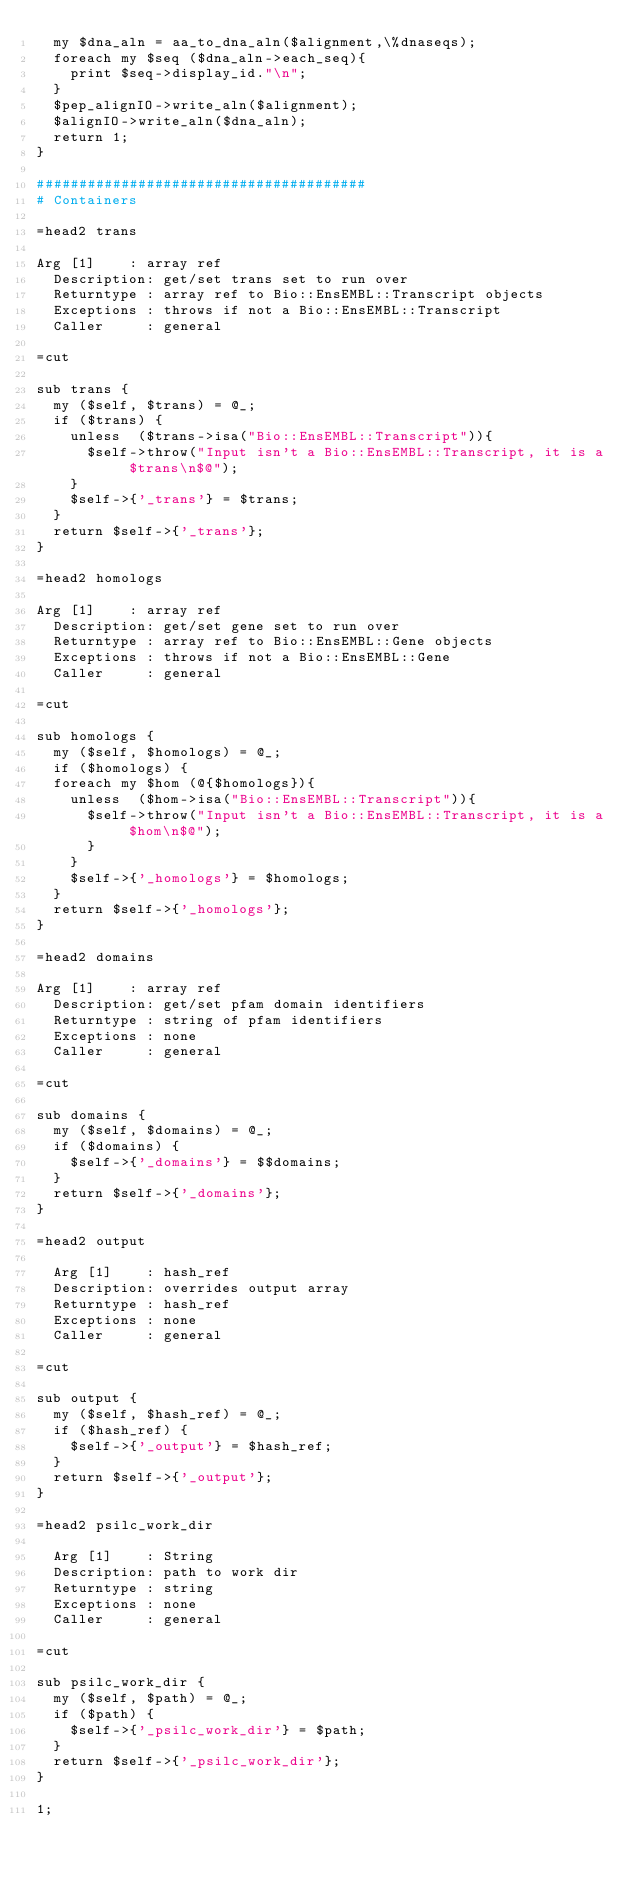<code> <loc_0><loc_0><loc_500><loc_500><_Perl_>  my $dna_aln = aa_to_dna_aln($alignment,\%dnaseqs);
  foreach my $seq ($dna_aln->each_seq){
    print $seq->display_id."\n";
  }  
  $pep_alignIO->write_aln($alignment);
  $alignIO->write_aln($dna_aln);
  return 1;
}

#######################################
# Containers

=head2 trans

Arg [1]    : array ref
  Description: get/set trans set to run over
  Returntype : array ref to Bio::EnsEMBL::Transcript objects
  Exceptions : throws if not a Bio::EnsEMBL::Transcript
  Caller     : general

=cut

sub trans {
  my ($self, $trans) = @_;
  if ($trans) {
    unless  ($trans->isa("Bio::EnsEMBL::Transcript")){
      $self->throw("Input isn't a Bio::EnsEMBL::Transcript, it is a $trans\n$@");
    }
    $self->{'_trans'} = $trans;
  }
  return $self->{'_trans'};
}

=head2 homologs

Arg [1]    : array ref
  Description: get/set gene set to run over
  Returntype : array ref to Bio::EnsEMBL::Gene objects
  Exceptions : throws if not a Bio::EnsEMBL::Gene
  Caller     : general

=cut

sub homologs {
  my ($self, $homologs) = @_;
  if ($homologs) {
  foreach my $hom (@{$homologs}){
    unless  ($hom->isa("Bio::EnsEMBL::Transcript")){
      $self->throw("Input isn't a Bio::EnsEMBL::Transcript, it is a $hom\n$@");
      }
    }
    $self->{'_homologs'} = $homologs;
  }
  return $self->{'_homologs'};
}

=head2 domains

Arg [1]    : array ref
  Description: get/set pfam domain identifiers
  Returntype : string of pfam identifiers
  Exceptions : none
  Caller     : general

=cut

sub domains {
  my ($self, $domains) = @_;
  if ($domains) {
    $self->{'_domains'} = $$domains;
  }
  return $self->{'_domains'};
}

=head2 output

  Arg [1]    : hash_ref
  Description: overrides output array
  Returntype : hash_ref
  Exceptions : none
  Caller     : general

=cut

sub output {
  my ($self, $hash_ref) = @_;
  if ($hash_ref) {
    $self->{'_output'} = $hash_ref;
  }
  return $self->{'_output'};
}

=head2 psilc_work_dir

  Arg [1]    : String
  Description: path to work dir
  Returntype : string
  Exceptions : none
  Caller     : general

=cut

sub psilc_work_dir {
  my ($self, $path) = @_;
  if ($path) {
    $self->{'_psilc_work_dir'} = $path;
  }
  return $self->{'_psilc_work_dir'};
}

1;

</code> 